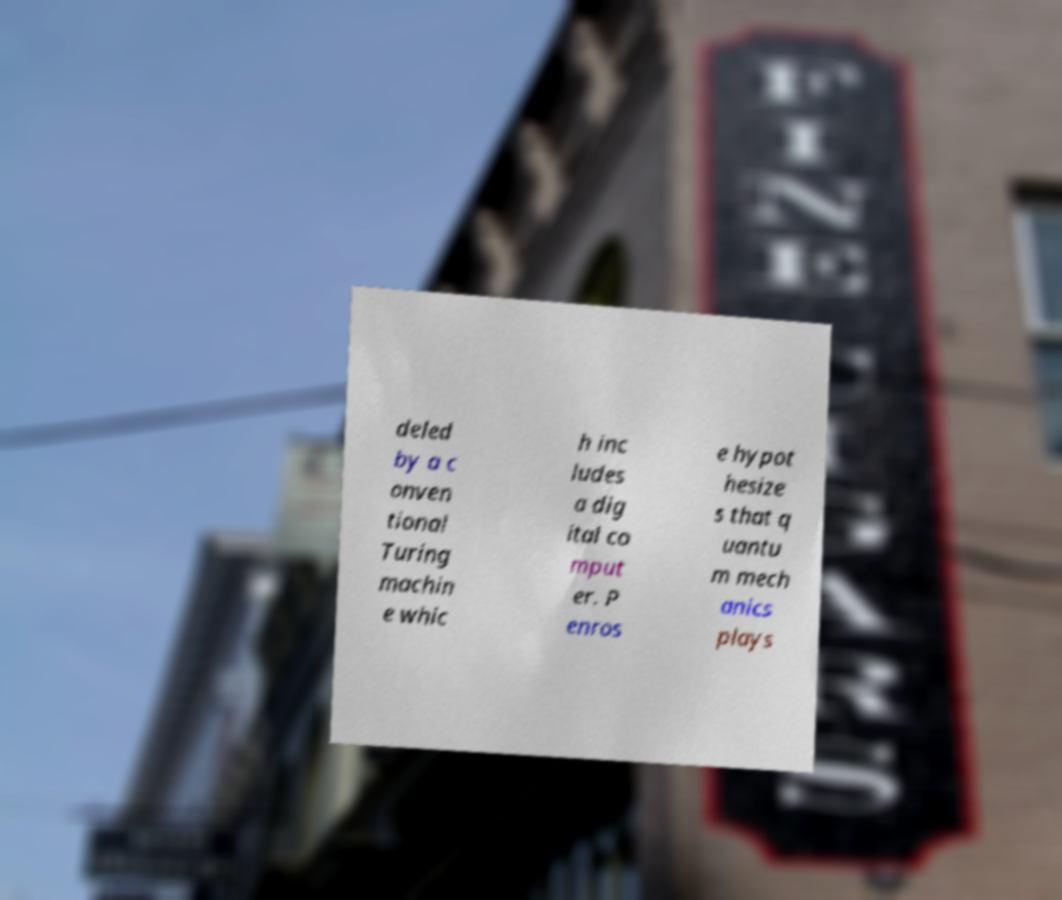Please read and relay the text visible in this image. What does it say? deled by a c onven tional Turing machin e whic h inc ludes a dig ital co mput er. P enros e hypot hesize s that q uantu m mech anics plays 